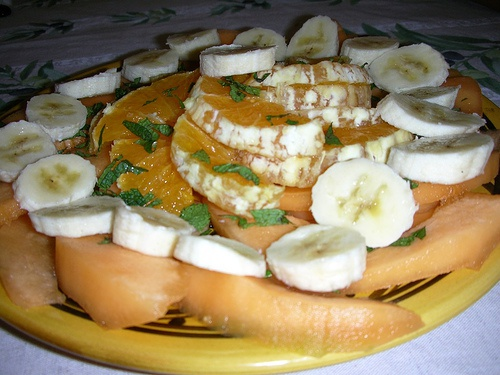Describe the objects in this image and their specific colors. I can see banana in black, gray, darkgray, and darkgreen tones, banana in black, ivory, khaki, and tan tones, orange in black, olive, ivory, tan, and beige tones, banana in black, white, darkgray, tan, and lightgray tones, and banana in black, ivory, beige, and tan tones in this image. 